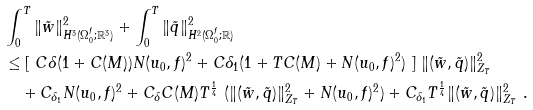<formula> <loc_0><loc_0><loc_500><loc_500>& \int _ { 0 } ^ { T } \| { \tilde { w } } \| ^ { 2 } _ { H ^ { 3 } ( \Omega _ { 0 } ^ { f } ; { \mathbb { R } } ^ { 3 } ) } + \int _ { 0 } ^ { T } \| { \tilde { q } } \| ^ { 2 } _ { H ^ { 2 } ( \Omega _ { 0 } ^ { f } ; { \mathbb { R } } ) } \ \\ & \leq [ \ C \delta ( 1 + C ( M ) ) N ( u _ { 0 } , f ) ^ { 2 } + C { \delta _ { 1 } } ( 1 + T C ( M ) + N ( u _ { 0 } , f ) ^ { 2 } ) \ ] \ \| ( \tilde { w } , \tilde { q } ) \| ^ { 2 } _ { Z _ { T } } \\ & \quad + C _ { \delta _ { 1 } } N ( u _ { 0 } , f ) ^ { 2 } + C _ { \delta } C ( M ) T ^ { \frac { 1 } { 4 } } \ ( \| ( \tilde { w } , \tilde { q } ) \| ^ { 2 } _ { Z _ { T } } + N ( u _ { 0 } , f ) ^ { 2 } ) + C _ { \delta _ { 1 } } T ^ { \frac { 1 } { 4 } } \| ( \tilde { w } , \tilde { q } ) \| ^ { 2 } _ { Z _ { T } } \ .</formula> 